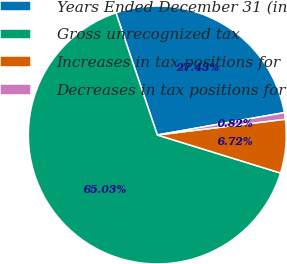Convert chart to OTSL. <chart><loc_0><loc_0><loc_500><loc_500><pie_chart><fcel>Years Ended December 31 (in<fcel>Gross unrecognized tax<fcel>Increases in tax positions for<fcel>Decreases in tax positions for<nl><fcel>27.43%<fcel>65.03%<fcel>6.72%<fcel>0.82%<nl></chart> 